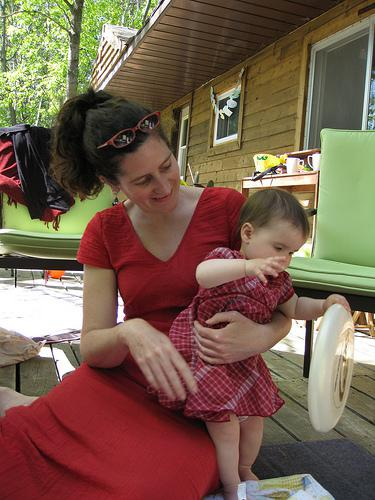Question: what is the baby holding?
Choices:
A. A pacifier.
B. A toy.
C. A frisbee.
D. A bottle.
Answer with the letter. Answer: C Question: what color is the lady's dress?
Choices:
A. Blue.
B. Purple.
C. Gold.
D. Red.
Answer with the letter. Answer: D Question: where are they?
Choices:
A. On an outdoor patio.
B. In a car.
C. In a house.
D. At a shopping mall.
Answer with the letter. Answer: A Question: who is holding the baby?
Choices:
A. A lady.
B. It's mother.
C. A friend.
D. A nurse.
Answer with the letter. Answer: A Question: how is the baby standing?
Choices:
A. Wobbly.
B. With help.
C. In a walker.
D. Holding onto the furniture.
Answer with the letter. Answer: B 